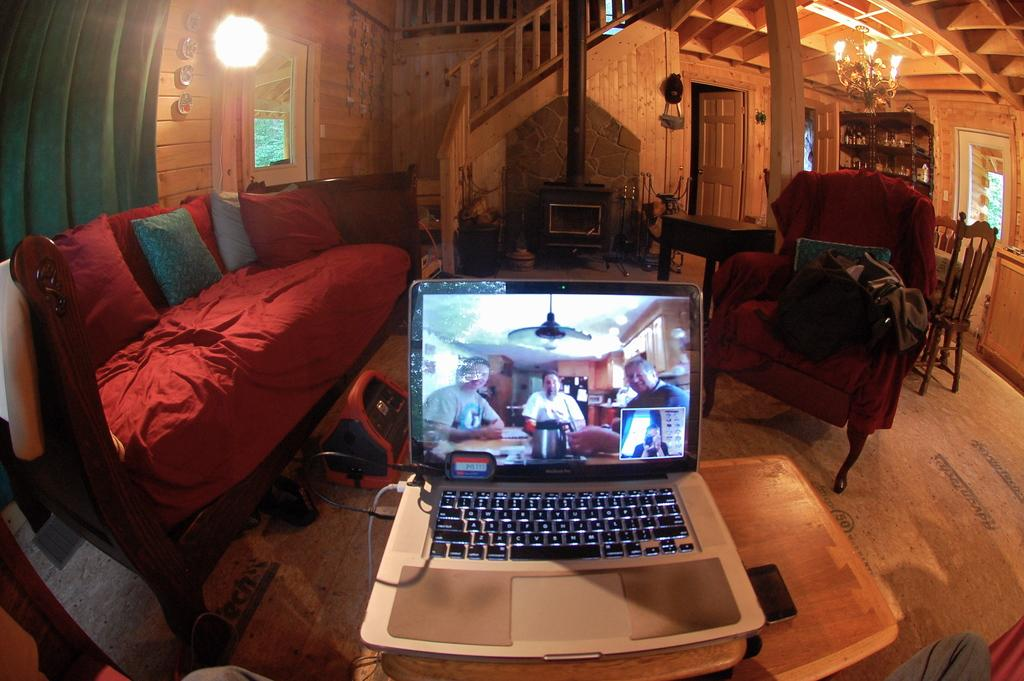What type of furniture is in the image? There is a sofa in the image. What electronic device is visible in the image? There is a laptop in the image. What living organism is present in the image? There is a plant in the image. What type of structure can be seen in the image? There is a building visible in the image. What is the source of illumination in the image? There is light in the image. What communication device is on the table in the image? There is a phone on the table in the image. Where is the goat located in the image? There is no goat present in the image. What type of chalk is used to draw on the table in the image? There is no chalk or drawing on the table in the image. 